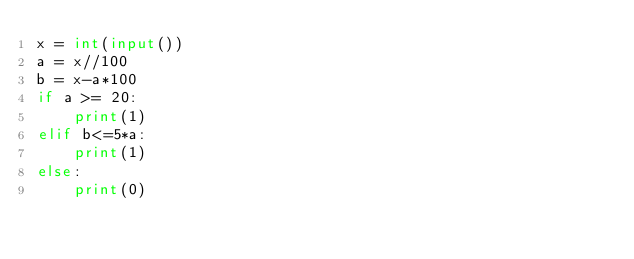Convert code to text. <code><loc_0><loc_0><loc_500><loc_500><_Python_>x = int(input())
a = x//100
b = x-a*100
if a >= 20:
    print(1)
elif b<=5*a:
    print(1)
else:
    print(0)</code> 